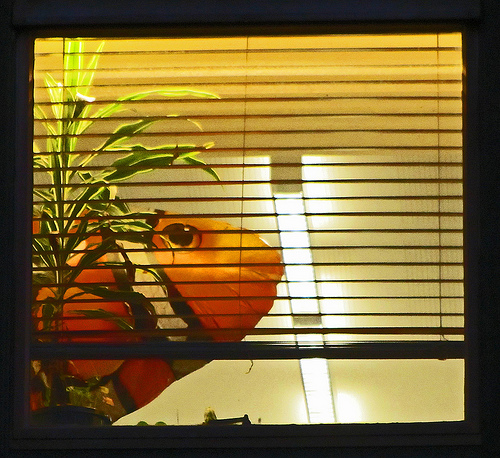<image>
Is there a clown fish in the air? Yes. The clown fish is contained within or inside the air, showing a containment relationship. Where is the fish in relation to the window? Is it in the window? Yes. The fish is contained within or inside the window, showing a containment relationship. 